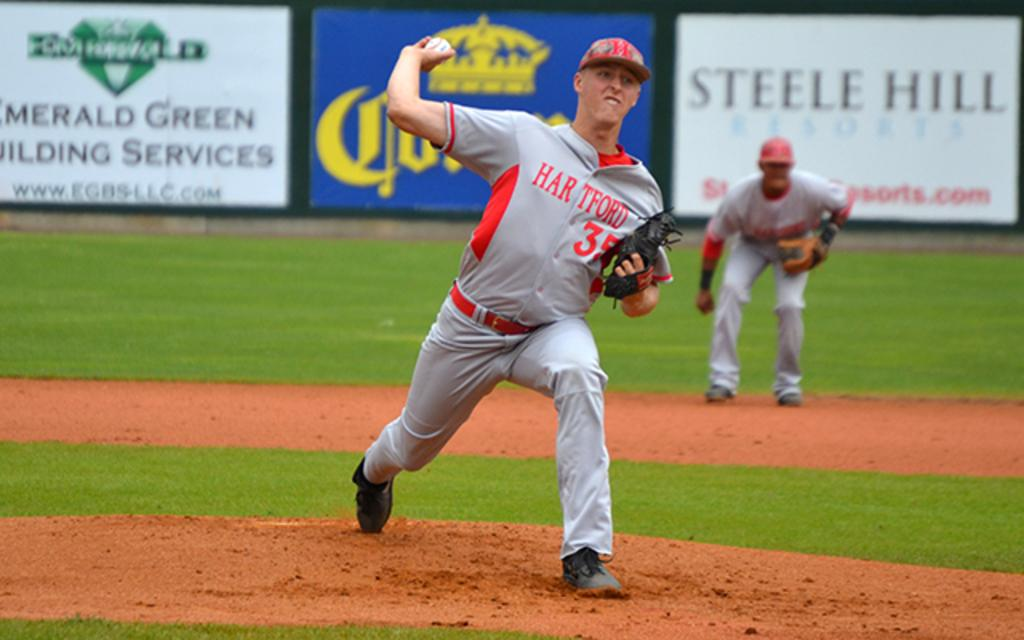<image>
Create a compact narrative representing the image presented. Baseball player wearing a jersey that says Hartford pitchign a ball. 